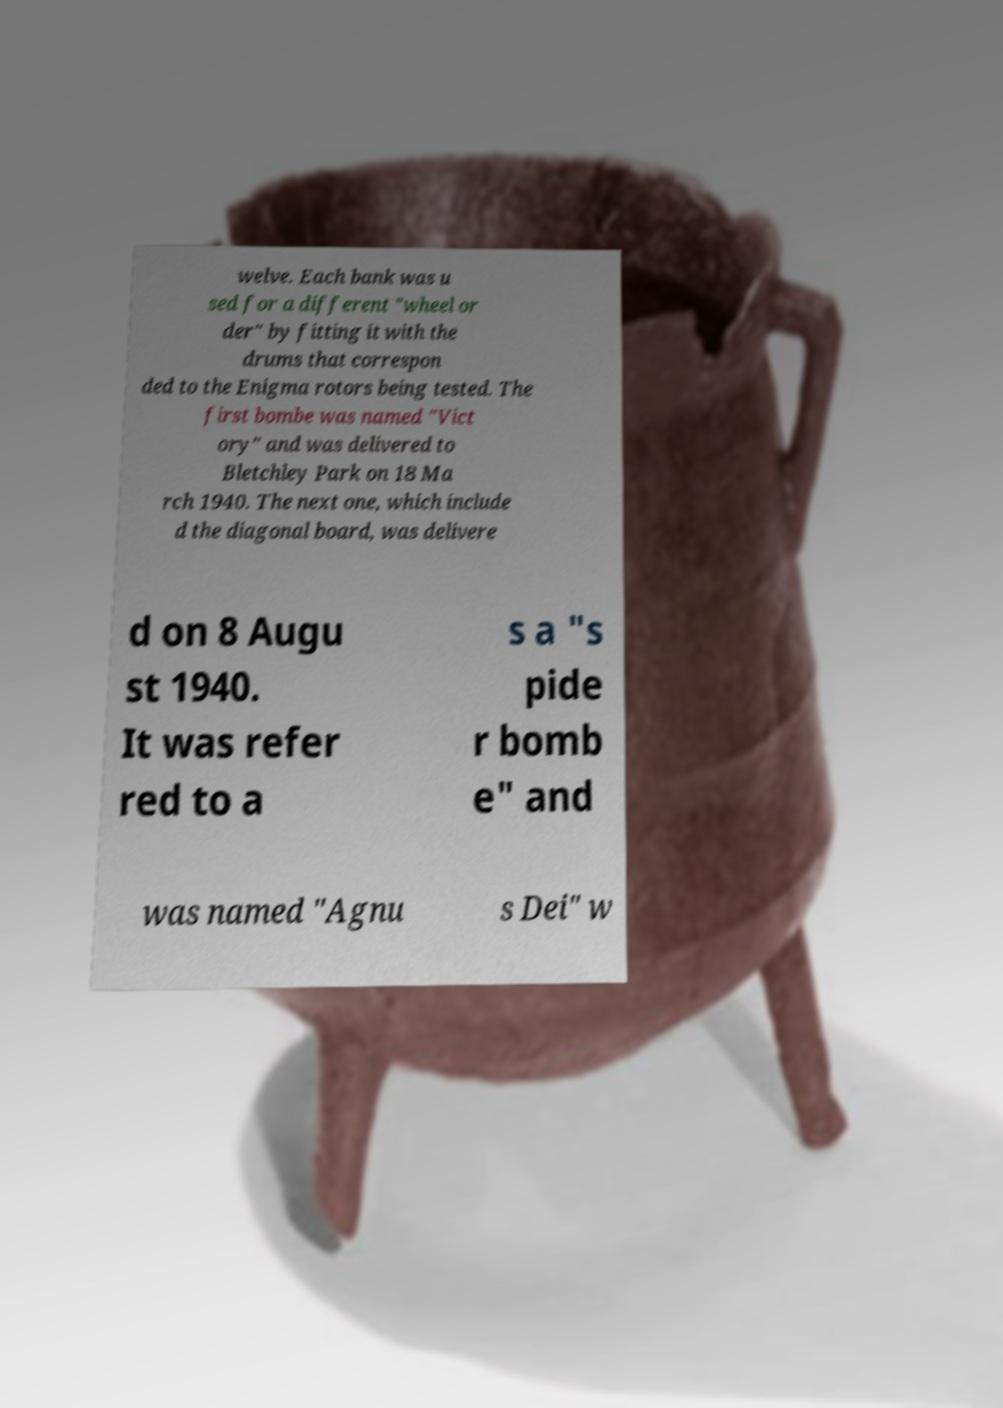What messages or text are displayed in this image? I need them in a readable, typed format. welve. Each bank was u sed for a different "wheel or der" by fitting it with the drums that correspon ded to the Enigma rotors being tested. The first bombe was named "Vict ory" and was delivered to Bletchley Park on 18 Ma rch 1940. The next one, which include d the diagonal board, was delivere d on 8 Augu st 1940. It was refer red to a s a "s pide r bomb e" and was named "Agnu s Dei" w 